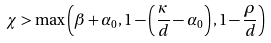<formula> <loc_0><loc_0><loc_500><loc_500>\chi > \max \left ( \beta + \alpha _ { 0 } , 1 - \left ( \frac { \kappa } { d } - \alpha _ { 0 } \right ) , 1 - \frac { \rho } { d } \right )</formula> 